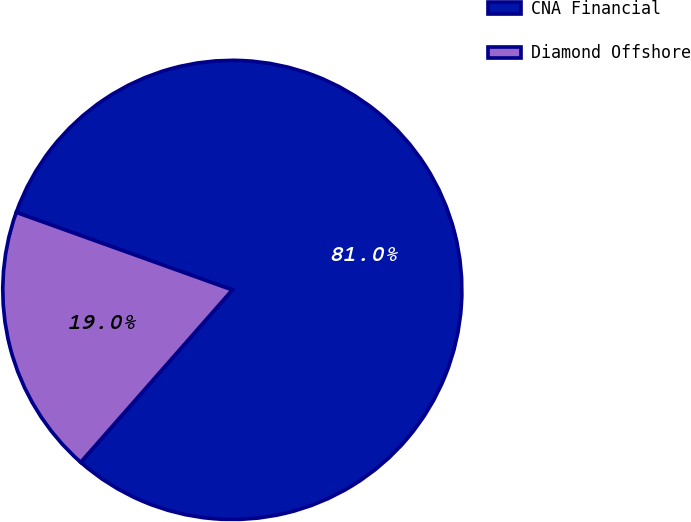<chart> <loc_0><loc_0><loc_500><loc_500><pie_chart><fcel>CNA Financial<fcel>Diamond Offshore<nl><fcel>81.0%<fcel>19.0%<nl></chart> 